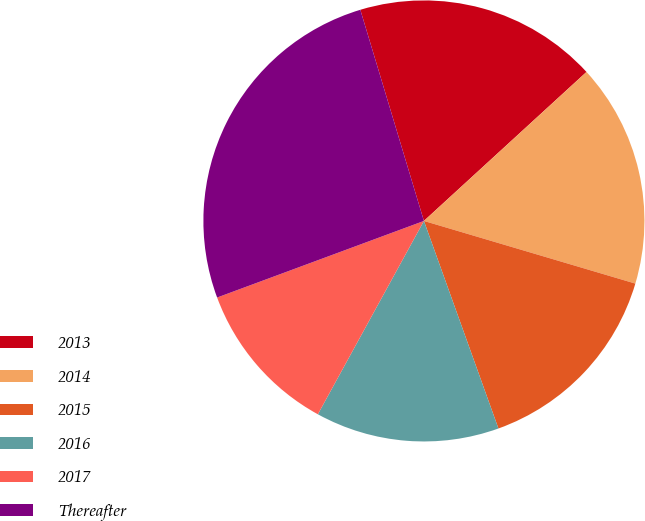Convert chart. <chart><loc_0><loc_0><loc_500><loc_500><pie_chart><fcel>2013<fcel>2014<fcel>2015<fcel>2016<fcel>2017<fcel>Thereafter<nl><fcel>17.85%<fcel>16.39%<fcel>14.93%<fcel>13.47%<fcel>11.37%<fcel>25.99%<nl></chart> 